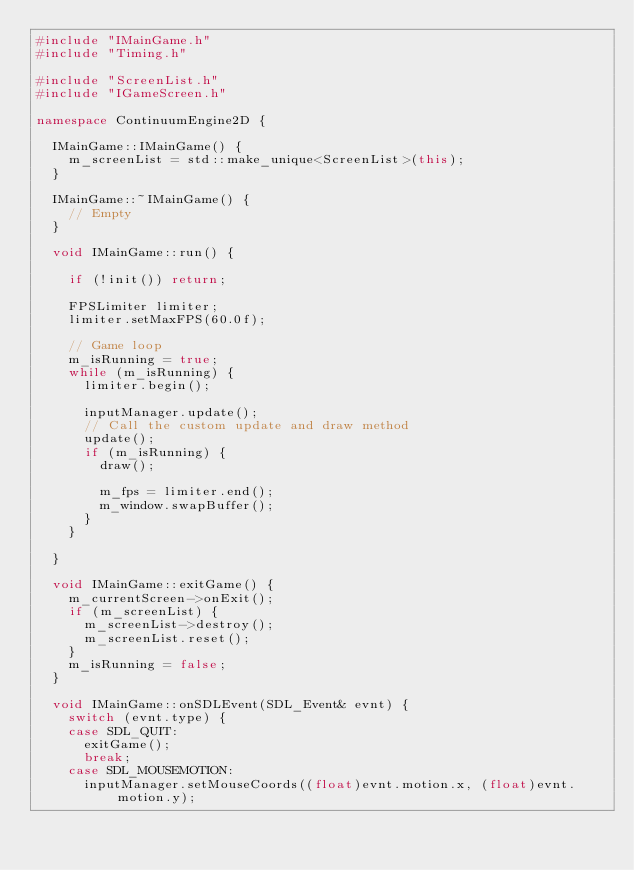Convert code to text. <code><loc_0><loc_0><loc_500><loc_500><_C++_>#include "IMainGame.h"
#include "Timing.h"

#include "ScreenList.h"
#include "IGameScreen.h"

namespace ContinuumEngine2D {

	IMainGame::IMainGame() {
		m_screenList = std::make_unique<ScreenList>(this);
	}

	IMainGame::~IMainGame() {
		// Empty
	}

	void IMainGame::run() {

		if (!init()) return;

		FPSLimiter limiter;
		limiter.setMaxFPS(60.0f);

		// Game loop
		m_isRunning = true;
		while (m_isRunning) {
			limiter.begin();

			inputManager.update();
			// Call the custom update and draw method
			update();
			if (m_isRunning) {
				draw();

				m_fps = limiter.end();
				m_window.swapBuffer();
			}
		}

	}

	void IMainGame::exitGame() {
		m_currentScreen->onExit();
		if (m_screenList) {
			m_screenList->destroy();
			m_screenList.reset();
		}
		m_isRunning = false;
	}

	void IMainGame::onSDLEvent(SDL_Event& evnt) {
		switch (evnt.type) {
		case SDL_QUIT:
			exitGame();
			break;
		case SDL_MOUSEMOTION:
			inputManager.setMouseCoords((float)evnt.motion.x, (float)evnt.motion.y);</code> 